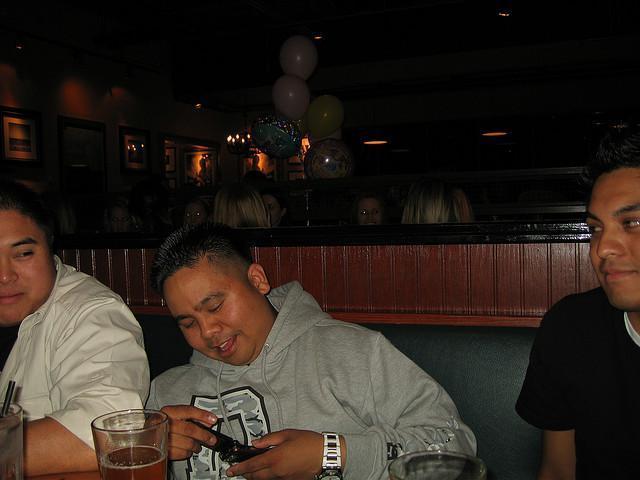How many people?
Give a very brief answer. 3. How many men are in this picture?
Give a very brief answer. 3. How many faces is written on the foto?
Give a very brief answer. 3. How many people are wearing a tie?
Give a very brief answer. 0. How many people can be seen?
Give a very brief answer. 5. How many cups can you see?
Give a very brief answer. 2. How many cats are shown?
Give a very brief answer. 0. 